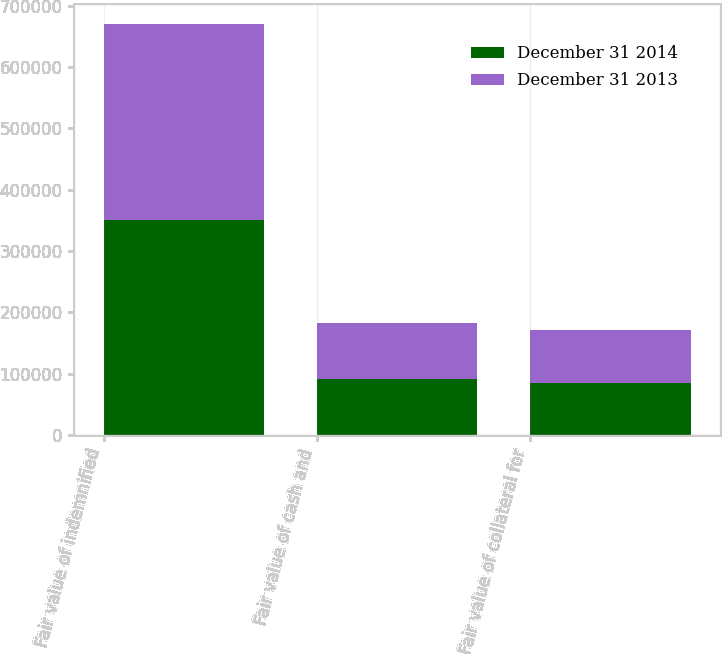Convert chart. <chart><loc_0><loc_0><loc_500><loc_500><stacked_bar_chart><ecel><fcel>Fair value of indemnified<fcel>Fair value of cash and<fcel>Fair value of collateral for<nl><fcel>December 31 2014<fcel>349766<fcel>90819<fcel>85309<nl><fcel>December 31 2013<fcel>320078<fcel>91097<fcel>85374<nl></chart> 